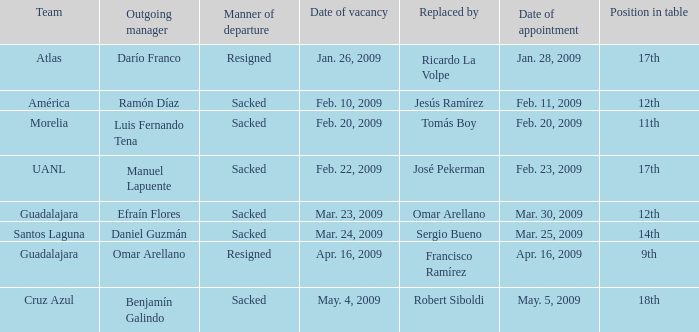What is Manner of Departure, when Outgoing Manager is "Luis Fernando Tena"? Sacked. 